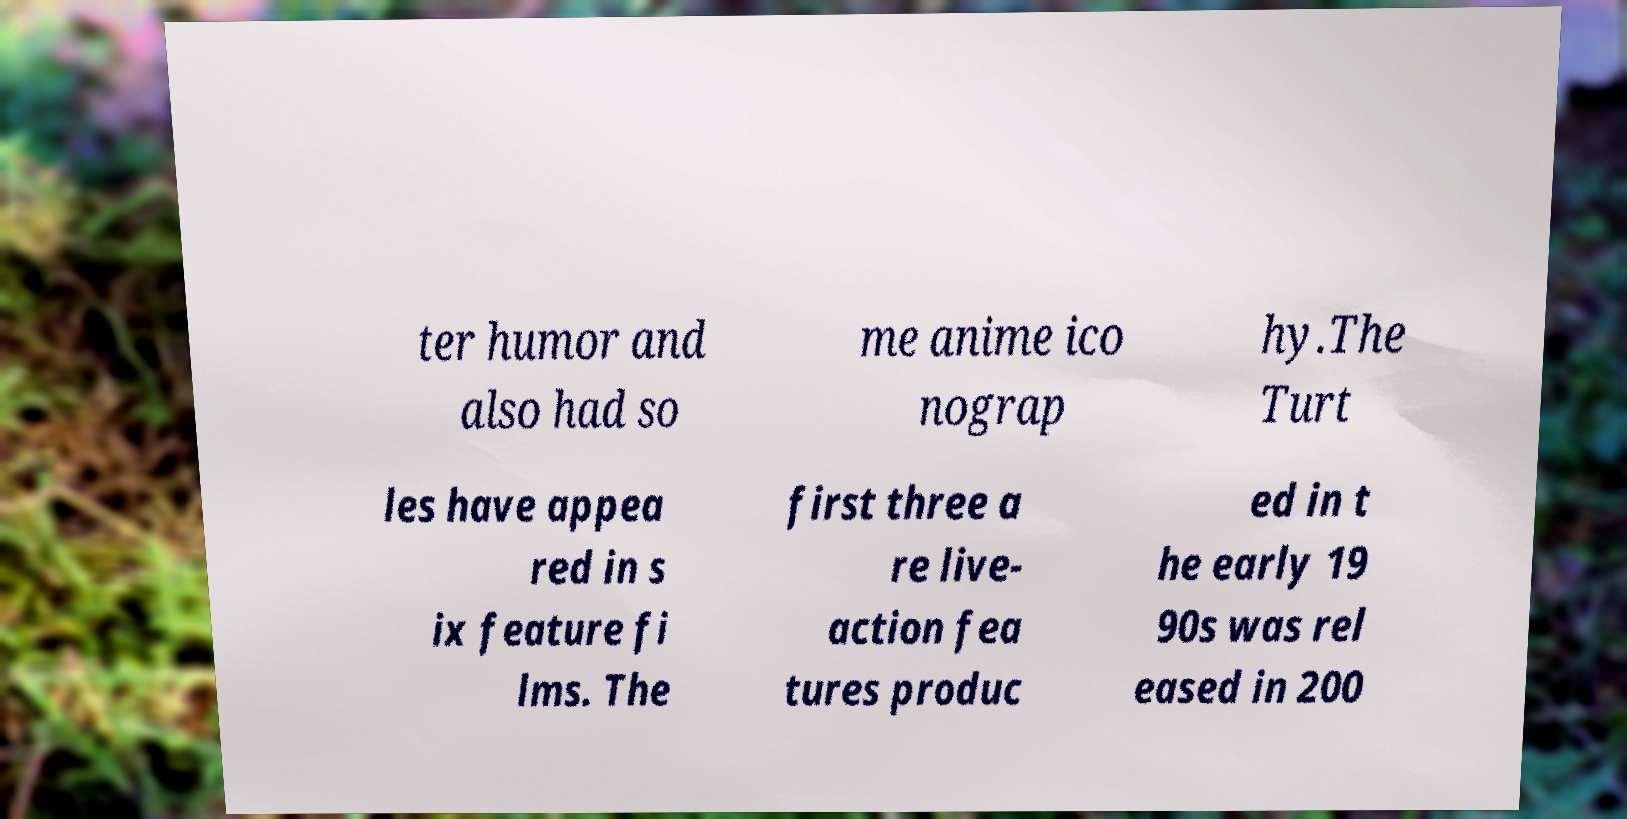I need the written content from this picture converted into text. Can you do that? ter humor and also had so me anime ico nograp hy.The Turt les have appea red in s ix feature fi lms. The first three a re live- action fea tures produc ed in t he early 19 90s was rel eased in 200 